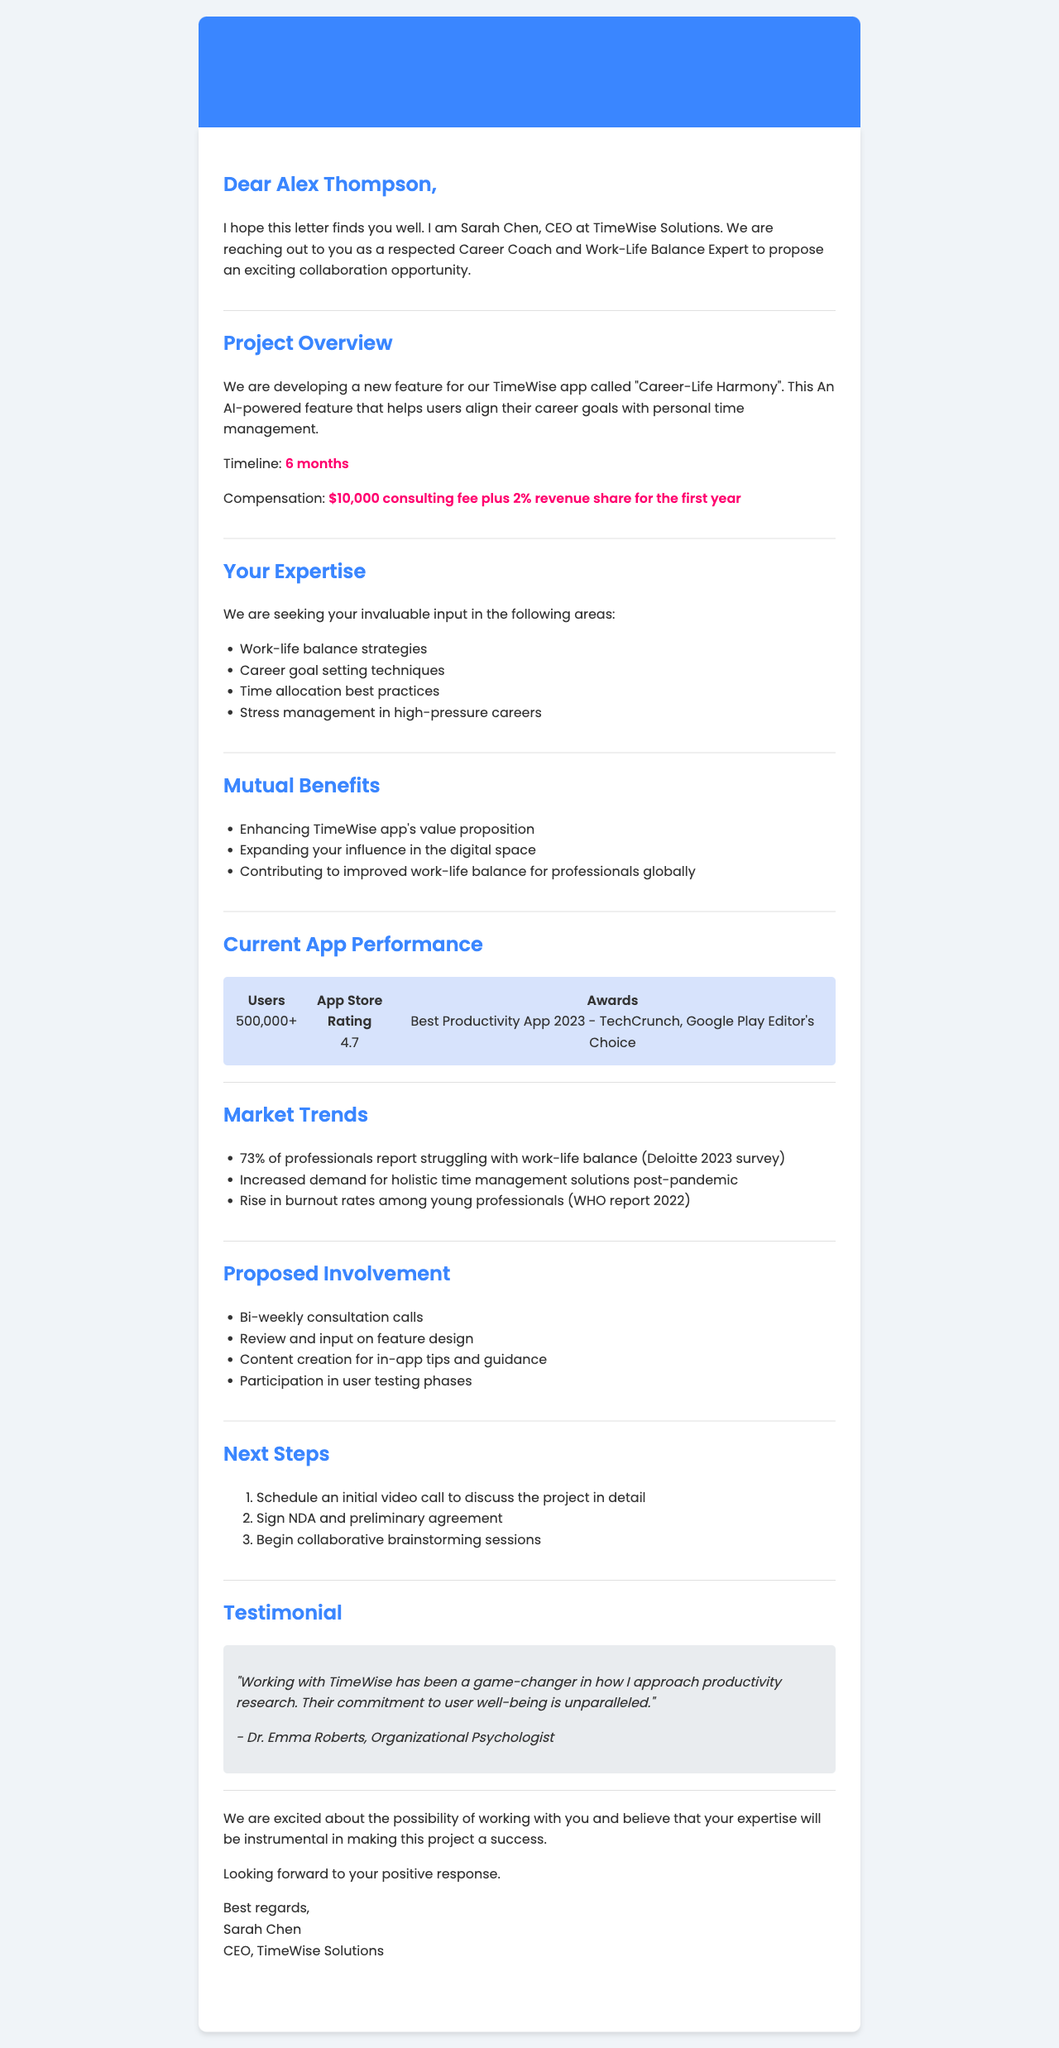What is the sender's name? The sender's name is explicitly stated in the document.
Answer: Sarah Chen What is the project name? The project name is highlighted in the collaboration proposal.
Answer: Career-Life Harmony What is the compensation amount proposed? The compensation is clearly listed in the document, including both the fee and the revenue share.
Answer: $10,000 consulting fee plus 2% revenue share for the first year How many users does the app currently have? The current user statistic is provided in the app performance section.
Answer: 500,000+ What percentage of professionals report struggling with work-life balance? This statistic is mentioned in the market trends section.
Answer: 73% What is the primary goal of the proposed feature? The proposed feature's description summarizes its main goal.
Answer: Help users align their career goals with personal time management What type of involvement is suggested for the recipient? The document lists several specific aspects of proposed involvement.
Answer: Bi-weekly consultation calls Who provided a testimonial for TimeWise Solutions? The document cites the person who gave a testimonial.
Answer: Dr. Emma Roberts What action should be taken first after reviewing the proposal? The document outlines the initial next steps after reading the proposal.
Answer: Schedule an initial video call to discuss the project in detail 